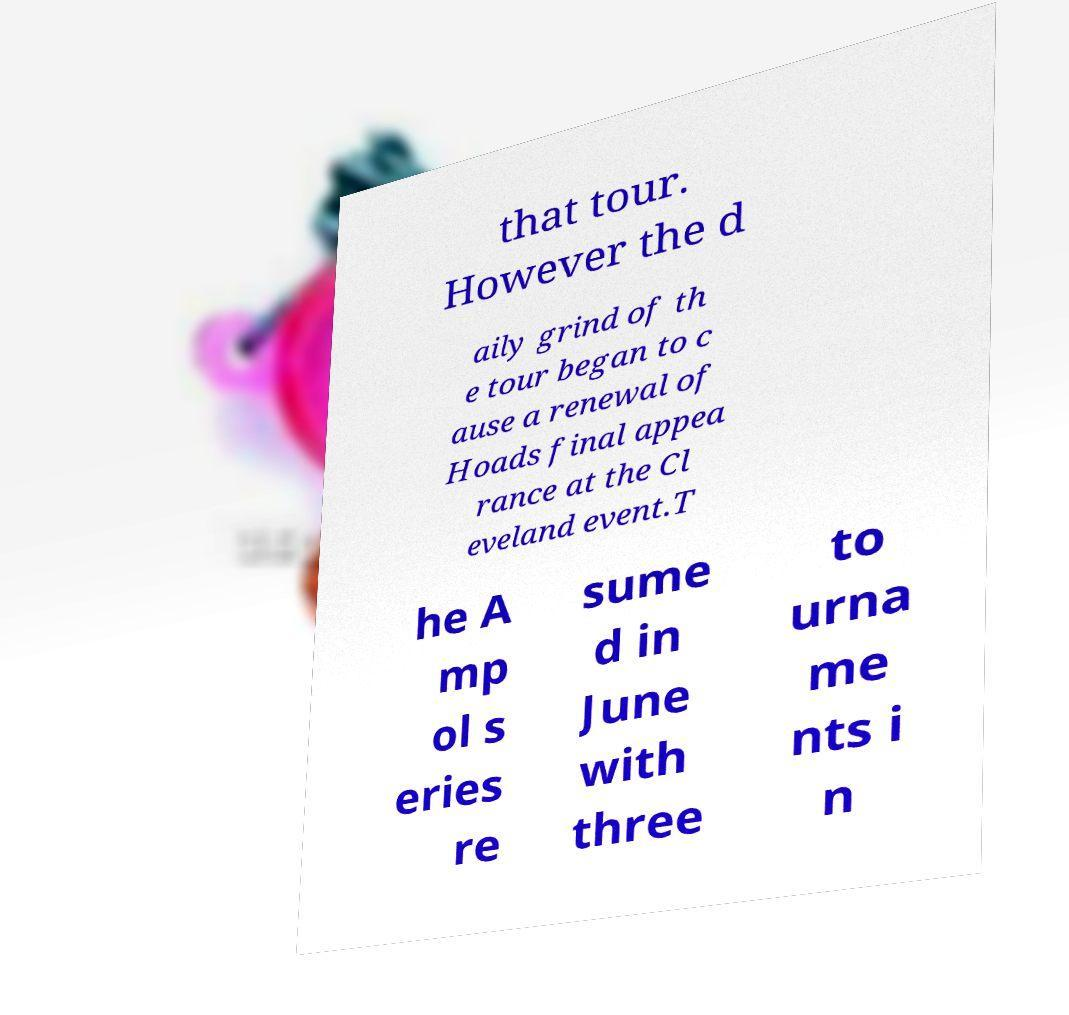Please read and relay the text visible in this image. What does it say? that tour. However the d aily grind of th e tour began to c ause a renewal of Hoads final appea rance at the Cl eveland event.T he A mp ol s eries re sume d in June with three to urna me nts i n 